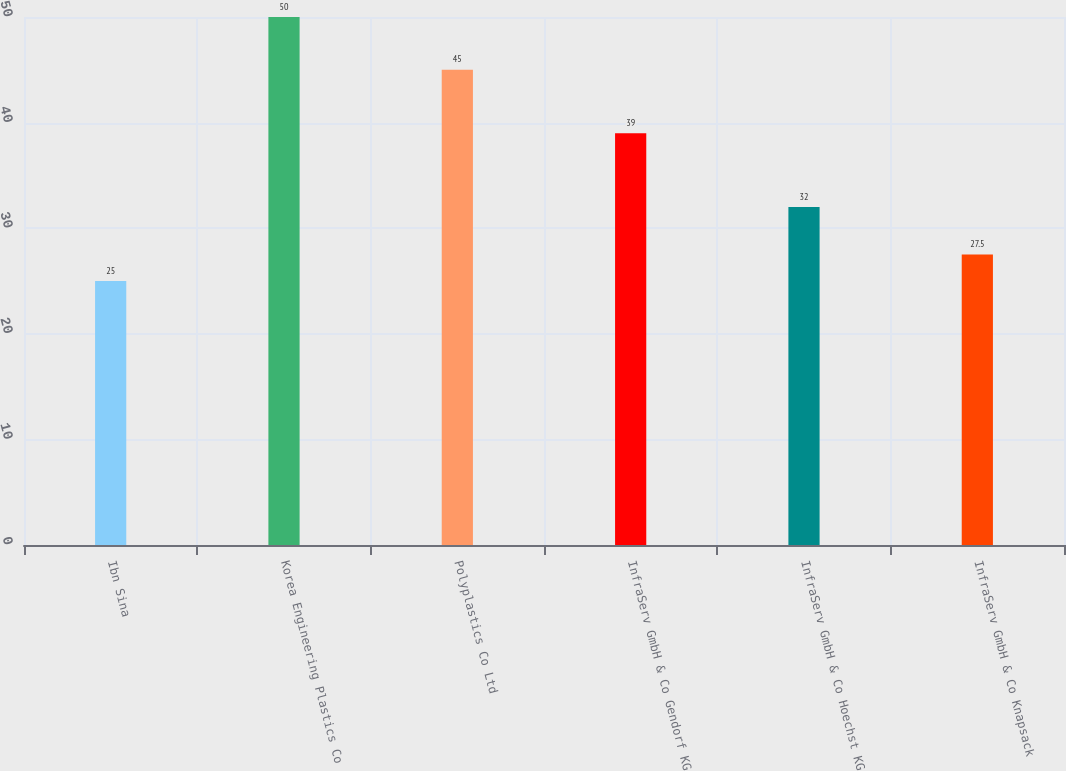Convert chart. <chart><loc_0><loc_0><loc_500><loc_500><bar_chart><fcel>Ibn Sina<fcel>Korea Engineering Plastics Co<fcel>Polyplastics Co Ltd<fcel>InfraServ GmbH & Co Gendorf KG<fcel>InfraServ GmbH & Co Hoechst KG<fcel>InfraServ GmbH & Co Knapsack<nl><fcel>25<fcel>50<fcel>45<fcel>39<fcel>32<fcel>27.5<nl></chart> 